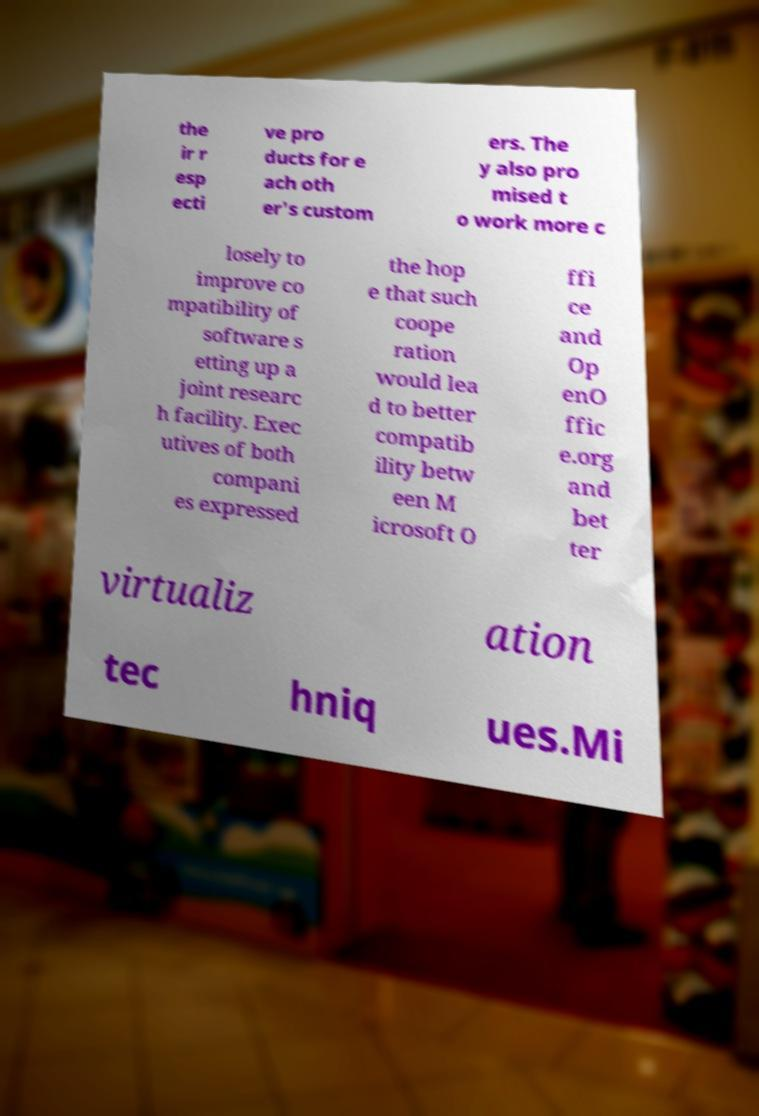Please identify and transcribe the text found in this image. the ir r esp ecti ve pro ducts for e ach oth er's custom ers. The y also pro mised t o work more c losely to improve co mpatibility of software s etting up a joint researc h facility. Exec utives of both compani es expressed the hop e that such coope ration would lea d to better compatib ility betw een M icrosoft O ffi ce and Op enO ffic e.org and bet ter virtualiz ation tec hniq ues.Mi 